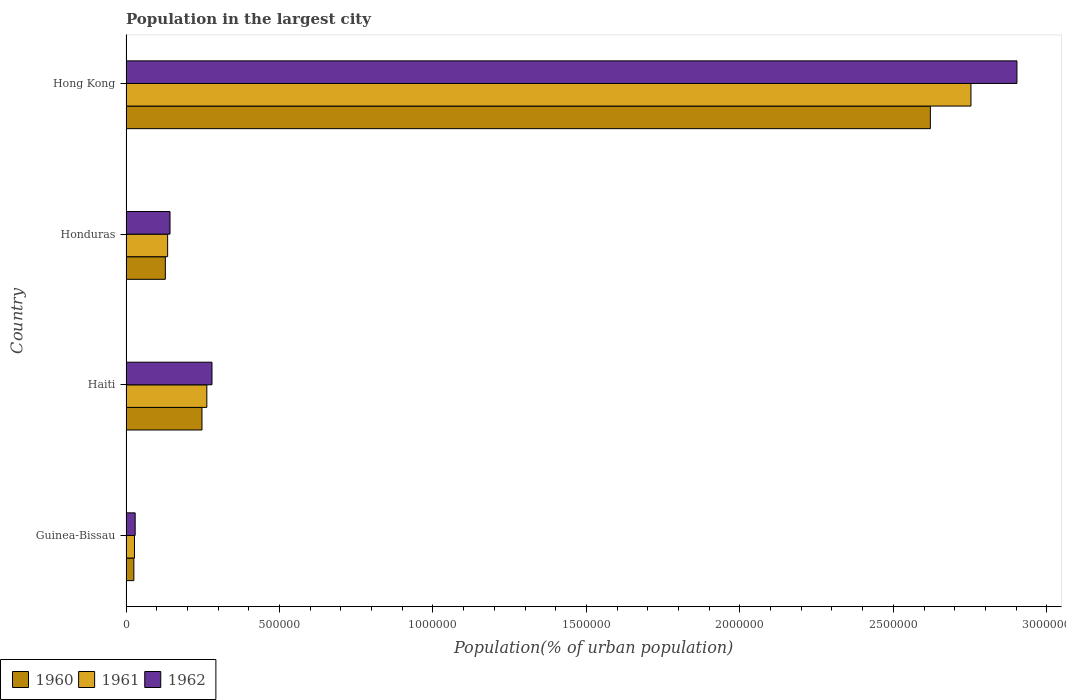How many groups of bars are there?
Make the answer very short. 4. Are the number of bars on each tick of the Y-axis equal?
Offer a very short reply. Yes. What is the label of the 2nd group of bars from the top?
Give a very brief answer. Honduras. What is the population in the largest city in 1961 in Honduras?
Your answer should be very brief. 1.36e+05. Across all countries, what is the maximum population in the largest city in 1962?
Your response must be concise. 2.90e+06. Across all countries, what is the minimum population in the largest city in 1960?
Offer a terse response. 2.56e+04. In which country was the population in the largest city in 1961 maximum?
Provide a short and direct response. Hong Kong. In which country was the population in the largest city in 1960 minimum?
Your answer should be compact. Guinea-Bissau. What is the total population in the largest city in 1962 in the graph?
Offer a very short reply. 3.36e+06. What is the difference between the population in the largest city in 1961 in Haiti and that in Hong Kong?
Make the answer very short. -2.49e+06. What is the difference between the population in the largest city in 1961 in Honduras and the population in the largest city in 1960 in Guinea-Bissau?
Make the answer very short. 1.10e+05. What is the average population in the largest city in 1961 per country?
Your response must be concise. 7.95e+05. What is the difference between the population in the largest city in 1960 and population in the largest city in 1962 in Hong Kong?
Your answer should be compact. -2.82e+05. What is the ratio of the population in the largest city in 1961 in Guinea-Bissau to that in Haiti?
Offer a very short reply. 0.1. Is the population in the largest city in 1960 in Guinea-Bissau less than that in Haiti?
Your answer should be very brief. Yes. What is the difference between the highest and the second highest population in the largest city in 1962?
Ensure brevity in your answer.  2.62e+06. What is the difference between the highest and the lowest population in the largest city in 1962?
Your answer should be compact. 2.87e+06. In how many countries, is the population in the largest city in 1960 greater than the average population in the largest city in 1960 taken over all countries?
Offer a terse response. 1. What does the 1st bar from the bottom in Honduras represents?
Give a very brief answer. 1960. How many bars are there?
Provide a succinct answer. 12. Are all the bars in the graph horizontal?
Provide a succinct answer. Yes. Does the graph contain any zero values?
Offer a very short reply. No. Where does the legend appear in the graph?
Your answer should be compact. Bottom left. What is the title of the graph?
Make the answer very short. Population in the largest city. What is the label or title of the X-axis?
Provide a succinct answer. Population(% of urban population). What is the label or title of the Y-axis?
Ensure brevity in your answer.  Country. What is the Population(% of urban population) of 1960 in Guinea-Bissau?
Give a very brief answer. 2.56e+04. What is the Population(% of urban population) of 1961 in Guinea-Bissau?
Keep it short and to the point. 2.76e+04. What is the Population(% of urban population) of 1962 in Guinea-Bissau?
Your response must be concise. 2.98e+04. What is the Population(% of urban population) in 1960 in Haiti?
Provide a succinct answer. 2.47e+05. What is the Population(% of urban population) of 1961 in Haiti?
Keep it short and to the point. 2.63e+05. What is the Population(% of urban population) of 1962 in Haiti?
Offer a terse response. 2.80e+05. What is the Population(% of urban population) of 1960 in Honduras?
Provide a succinct answer. 1.28e+05. What is the Population(% of urban population) of 1961 in Honduras?
Provide a succinct answer. 1.36e+05. What is the Population(% of urban population) in 1962 in Honduras?
Offer a very short reply. 1.43e+05. What is the Population(% of urban population) in 1960 in Hong Kong?
Provide a short and direct response. 2.62e+06. What is the Population(% of urban population) in 1961 in Hong Kong?
Keep it short and to the point. 2.75e+06. What is the Population(% of urban population) of 1962 in Hong Kong?
Provide a short and direct response. 2.90e+06. Across all countries, what is the maximum Population(% of urban population) in 1960?
Offer a very short reply. 2.62e+06. Across all countries, what is the maximum Population(% of urban population) in 1961?
Provide a short and direct response. 2.75e+06. Across all countries, what is the maximum Population(% of urban population) in 1962?
Offer a very short reply. 2.90e+06. Across all countries, what is the minimum Population(% of urban population) in 1960?
Offer a terse response. 2.56e+04. Across all countries, what is the minimum Population(% of urban population) in 1961?
Provide a short and direct response. 2.76e+04. Across all countries, what is the minimum Population(% of urban population) of 1962?
Provide a short and direct response. 2.98e+04. What is the total Population(% of urban population) of 1960 in the graph?
Make the answer very short. 3.02e+06. What is the total Population(% of urban population) of 1961 in the graph?
Provide a succinct answer. 3.18e+06. What is the total Population(% of urban population) in 1962 in the graph?
Make the answer very short. 3.36e+06. What is the difference between the Population(% of urban population) of 1960 in Guinea-Bissau and that in Haiti?
Offer a terse response. -2.22e+05. What is the difference between the Population(% of urban population) of 1961 in Guinea-Bissau and that in Haiti?
Your response must be concise. -2.36e+05. What is the difference between the Population(% of urban population) in 1962 in Guinea-Bissau and that in Haiti?
Your answer should be compact. -2.50e+05. What is the difference between the Population(% of urban population) of 1960 in Guinea-Bissau and that in Honduras?
Your response must be concise. -1.03e+05. What is the difference between the Population(% of urban population) of 1961 in Guinea-Bissau and that in Honduras?
Offer a very short reply. -1.08e+05. What is the difference between the Population(% of urban population) in 1962 in Guinea-Bissau and that in Honduras?
Your answer should be compact. -1.14e+05. What is the difference between the Population(% of urban population) in 1960 in Guinea-Bissau and that in Hong Kong?
Offer a very short reply. -2.59e+06. What is the difference between the Population(% of urban population) of 1961 in Guinea-Bissau and that in Hong Kong?
Provide a succinct answer. -2.73e+06. What is the difference between the Population(% of urban population) of 1962 in Guinea-Bissau and that in Hong Kong?
Make the answer very short. -2.87e+06. What is the difference between the Population(% of urban population) of 1960 in Haiti and that in Honduras?
Provide a succinct answer. 1.19e+05. What is the difference between the Population(% of urban population) in 1961 in Haiti and that in Honduras?
Your answer should be compact. 1.28e+05. What is the difference between the Population(% of urban population) of 1962 in Haiti and that in Honduras?
Offer a very short reply. 1.37e+05. What is the difference between the Population(% of urban population) in 1960 in Haiti and that in Hong Kong?
Provide a short and direct response. -2.37e+06. What is the difference between the Population(% of urban population) in 1961 in Haiti and that in Hong Kong?
Keep it short and to the point. -2.49e+06. What is the difference between the Population(% of urban population) of 1962 in Haiti and that in Hong Kong?
Keep it short and to the point. -2.62e+06. What is the difference between the Population(% of urban population) in 1960 in Honduras and that in Hong Kong?
Make the answer very short. -2.49e+06. What is the difference between the Population(% of urban population) in 1961 in Honduras and that in Hong Kong?
Offer a very short reply. -2.62e+06. What is the difference between the Population(% of urban population) of 1962 in Honduras and that in Hong Kong?
Offer a terse response. -2.76e+06. What is the difference between the Population(% of urban population) of 1960 in Guinea-Bissau and the Population(% of urban population) of 1961 in Haiti?
Ensure brevity in your answer.  -2.38e+05. What is the difference between the Population(% of urban population) in 1960 in Guinea-Bissau and the Population(% of urban population) in 1962 in Haiti?
Your response must be concise. -2.55e+05. What is the difference between the Population(% of urban population) of 1961 in Guinea-Bissau and the Population(% of urban population) of 1962 in Haiti?
Offer a terse response. -2.52e+05. What is the difference between the Population(% of urban population) of 1960 in Guinea-Bissau and the Population(% of urban population) of 1961 in Honduras?
Your answer should be very brief. -1.10e+05. What is the difference between the Population(% of urban population) of 1960 in Guinea-Bissau and the Population(% of urban population) of 1962 in Honduras?
Offer a terse response. -1.18e+05. What is the difference between the Population(% of urban population) in 1961 in Guinea-Bissau and the Population(% of urban population) in 1962 in Honduras?
Give a very brief answer. -1.16e+05. What is the difference between the Population(% of urban population) in 1960 in Guinea-Bissau and the Population(% of urban population) in 1961 in Hong Kong?
Give a very brief answer. -2.73e+06. What is the difference between the Population(% of urban population) of 1960 in Guinea-Bissau and the Population(% of urban population) of 1962 in Hong Kong?
Keep it short and to the point. -2.88e+06. What is the difference between the Population(% of urban population) in 1961 in Guinea-Bissau and the Population(% of urban population) in 1962 in Hong Kong?
Offer a terse response. -2.88e+06. What is the difference between the Population(% of urban population) in 1960 in Haiti and the Population(% of urban population) in 1961 in Honduras?
Provide a short and direct response. 1.12e+05. What is the difference between the Population(% of urban population) in 1960 in Haiti and the Population(% of urban population) in 1962 in Honduras?
Ensure brevity in your answer.  1.04e+05. What is the difference between the Population(% of urban population) of 1961 in Haiti and the Population(% of urban population) of 1962 in Honduras?
Your answer should be compact. 1.20e+05. What is the difference between the Population(% of urban population) in 1960 in Haiti and the Population(% of urban population) in 1961 in Hong Kong?
Your answer should be very brief. -2.51e+06. What is the difference between the Population(% of urban population) in 1960 in Haiti and the Population(% of urban population) in 1962 in Hong Kong?
Give a very brief answer. -2.66e+06. What is the difference between the Population(% of urban population) in 1961 in Haiti and the Population(% of urban population) in 1962 in Hong Kong?
Provide a succinct answer. -2.64e+06. What is the difference between the Population(% of urban population) of 1960 in Honduras and the Population(% of urban population) of 1961 in Hong Kong?
Your answer should be very brief. -2.62e+06. What is the difference between the Population(% of urban population) of 1960 in Honduras and the Population(% of urban population) of 1962 in Hong Kong?
Ensure brevity in your answer.  -2.77e+06. What is the difference between the Population(% of urban population) in 1961 in Honduras and the Population(% of urban population) in 1962 in Hong Kong?
Provide a succinct answer. -2.77e+06. What is the average Population(% of urban population) of 1960 per country?
Provide a succinct answer. 7.55e+05. What is the average Population(% of urban population) of 1961 per country?
Give a very brief answer. 7.95e+05. What is the average Population(% of urban population) of 1962 per country?
Provide a short and direct response. 8.39e+05. What is the difference between the Population(% of urban population) in 1960 and Population(% of urban population) in 1961 in Guinea-Bissau?
Make the answer very short. -2047. What is the difference between the Population(% of urban population) of 1960 and Population(% of urban population) of 1962 in Guinea-Bissau?
Offer a very short reply. -4261. What is the difference between the Population(% of urban population) in 1961 and Population(% of urban population) in 1962 in Guinea-Bissau?
Your answer should be compact. -2214. What is the difference between the Population(% of urban population) of 1960 and Population(% of urban population) of 1961 in Haiti?
Ensure brevity in your answer.  -1.58e+04. What is the difference between the Population(% of urban population) in 1960 and Population(% of urban population) in 1962 in Haiti?
Provide a short and direct response. -3.26e+04. What is the difference between the Population(% of urban population) of 1961 and Population(% of urban population) of 1962 in Haiti?
Give a very brief answer. -1.68e+04. What is the difference between the Population(% of urban population) in 1960 and Population(% of urban population) in 1961 in Honduras?
Ensure brevity in your answer.  -7454. What is the difference between the Population(% of urban population) in 1960 and Population(% of urban population) in 1962 in Honduras?
Your answer should be very brief. -1.52e+04. What is the difference between the Population(% of urban population) of 1961 and Population(% of urban population) of 1962 in Honduras?
Your answer should be compact. -7731. What is the difference between the Population(% of urban population) in 1960 and Population(% of urban population) in 1961 in Hong Kong?
Your answer should be compact. -1.32e+05. What is the difference between the Population(% of urban population) of 1960 and Population(% of urban population) of 1962 in Hong Kong?
Keep it short and to the point. -2.82e+05. What is the difference between the Population(% of urban population) in 1961 and Population(% of urban population) in 1962 in Hong Kong?
Your response must be concise. -1.50e+05. What is the ratio of the Population(% of urban population) of 1960 in Guinea-Bissau to that in Haiti?
Provide a succinct answer. 0.1. What is the ratio of the Population(% of urban population) in 1961 in Guinea-Bissau to that in Haiti?
Offer a very short reply. 0.1. What is the ratio of the Population(% of urban population) in 1962 in Guinea-Bissau to that in Haiti?
Provide a short and direct response. 0.11. What is the ratio of the Population(% of urban population) in 1960 in Guinea-Bissau to that in Honduras?
Your answer should be very brief. 0.2. What is the ratio of the Population(% of urban population) in 1961 in Guinea-Bissau to that in Honduras?
Offer a terse response. 0.2. What is the ratio of the Population(% of urban population) of 1962 in Guinea-Bissau to that in Honduras?
Offer a very short reply. 0.21. What is the ratio of the Population(% of urban population) of 1960 in Guinea-Bissau to that in Hong Kong?
Provide a succinct answer. 0.01. What is the ratio of the Population(% of urban population) of 1961 in Guinea-Bissau to that in Hong Kong?
Your response must be concise. 0.01. What is the ratio of the Population(% of urban population) in 1962 in Guinea-Bissau to that in Hong Kong?
Provide a succinct answer. 0.01. What is the ratio of the Population(% of urban population) in 1960 in Haiti to that in Honduras?
Provide a short and direct response. 1.93. What is the ratio of the Population(% of urban population) of 1961 in Haiti to that in Honduras?
Your response must be concise. 1.94. What is the ratio of the Population(% of urban population) in 1962 in Haiti to that in Honduras?
Your answer should be compact. 1.95. What is the ratio of the Population(% of urban population) of 1960 in Haiti to that in Hong Kong?
Ensure brevity in your answer.  0.09. What is the ratio of the Population(% of urban population) in 1961 in Haiti to that in Hong Kong?
Offer a terse response. 0.1. What is the ratio of the Population(% of urban population) in 1962 in Haiti to that in Hong Kong?
Offer a terse response. 0.1. What is the ratio of the Population(% of urban population) in 1960 in Honduras to that in Hong Kong?
Give a very brief answer. 0.05. What is the ratio of the Population(% of urban population) in 1961 in Honduras to that in Hong Kong?
Make the answer very short. 0.05. What is the ratio of the Population(% of urban population) of 1962 in Honduras to that in Hong Kong?
Provide a succinct answer. 0.05. What is the difference between the highest and the second highest Population(% of urban population) of 1960?
Offer a terse response. 2.37e+06. What is the difference between the highest and the second highest Population(% of urban population) in 1961?
Keep it short and to the point. 2.49e+06. What is the difference between the highest and the second highest Population(% of urban population) in 1962?
Keep it short and to the point. 2.62e+06. What is the difference between the highest and the lowest Population(% of urban population) in 1960?
Provide a succinct answer. 2.59e+06. What is the difference between the highest and the lowest Population(% of urban population) in 1961?
Your answer should be compact. 2.73e+06. What is the difference between the highest and the lowest Population(% of urban population) in 1962?
Offer a terse response. 2.87e+06. 